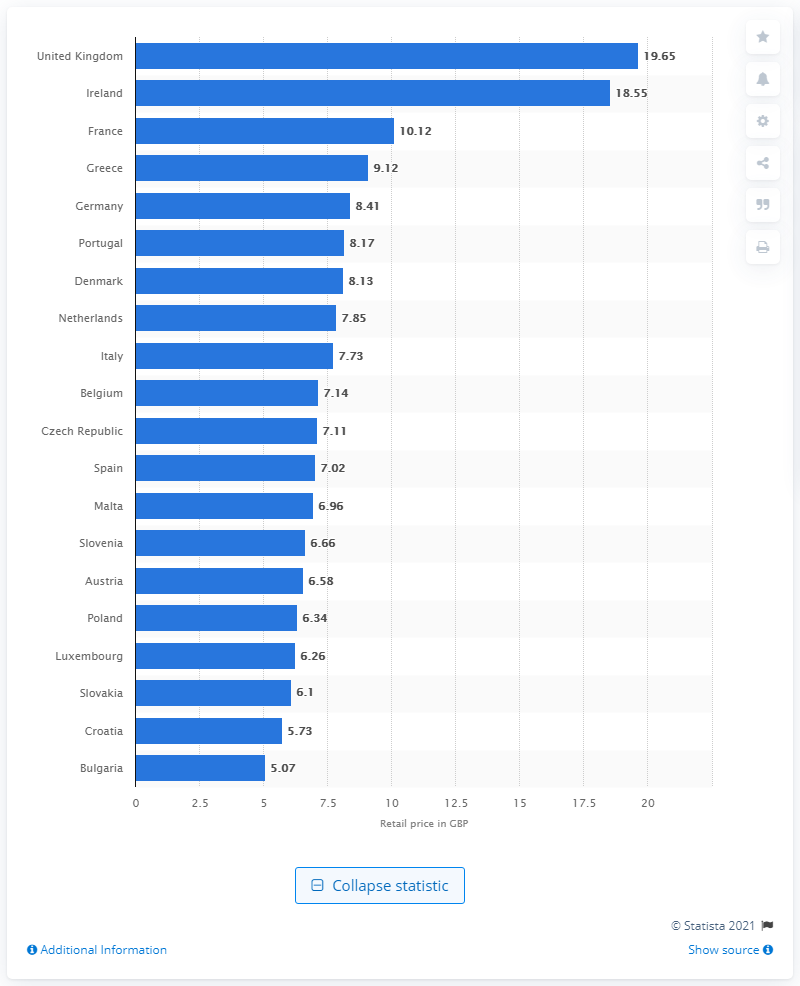Point out several critical features in this image. In April 2016, the retail price of hand rolling tobacco in the UK was 19.65 pounds. 